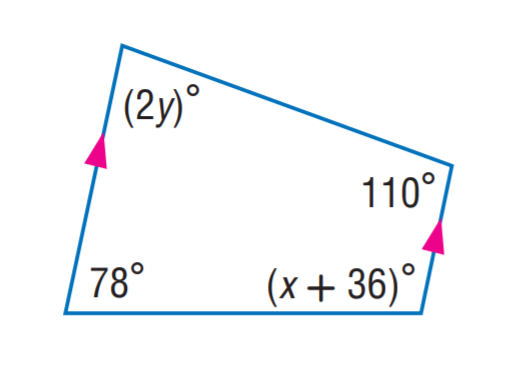Question: Find y.
Choices:
A. 35
B. 36
C. 66
D. 78
Answer with the letter. Answer: A Question: Find x.
Choices:
A. 35
B. 36
C. 66
D. 78
Answer with the letter. Answer: C 